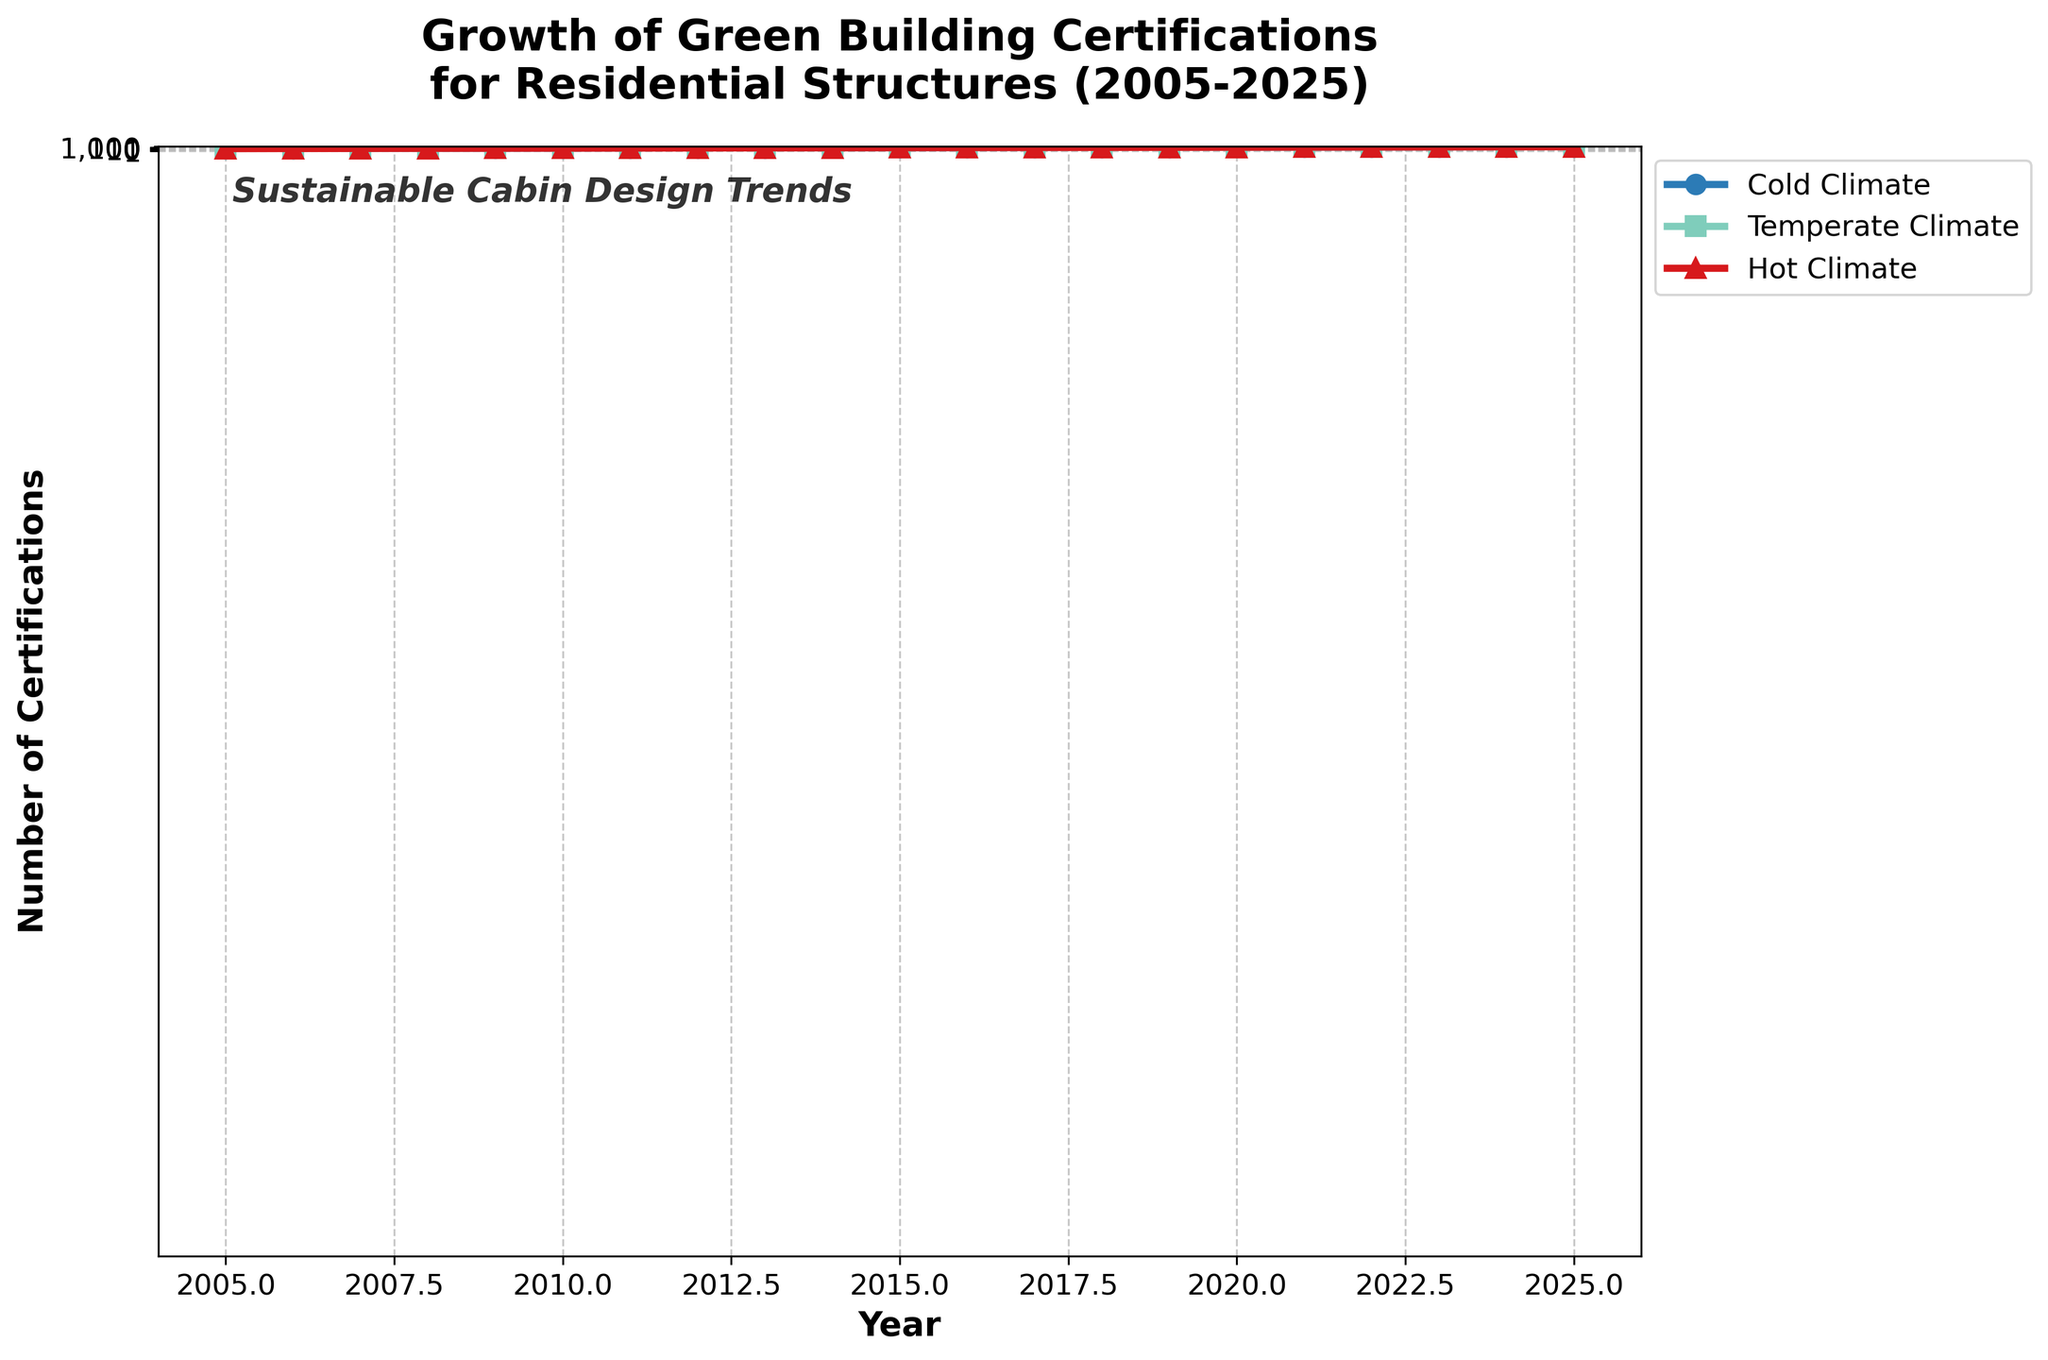What is the overall trend of green building certifications for residential structures in the Cold Climate zone from 2005 to 2025? The figure shows a steadily increasing trend in the number of green building certifications in the Cold Climate zone from 2005 to 2025. This is indicated by the upward slope of the line representing the Cold Climate zone throughout the years.
Answer: Steadily increasing trend Which climate zone exhibited the highest number of certifications in 2020? By examining the figure for the year 2020, the Temperate Climate zone has the highest data point compared to Cold and Hot Climate zones. The green line representing the Temperate Climate zone is significantly above the others for that year.
Answer: Temperate Climate How does the growth rate of certifications in the Hot Climate zone compare to the Cold Climate zone between 2010 and 2015? From 2010 to 2015, the number of certifications in the Hot Climate zone increased from 205 to 545, while in the Cold Climate zone, it increased from 255 to 665. Calculating the growth: Hot Climate increased by 340 (545-205) and Cold Climate increased by 410 (665-255). Thus, the Cold Climate zone had a higher growth rate in certifications during this period.
Answer: Cold Climate had a higher growth rate In which year did the Cold Climate zone surpass 1000 certifications? By analyzing the figure, the Cold Climate line surpasses the 1000-certification mark between 2016 and 2017. The exact year can be determined as 2017 based on the data progression.
Answer: 2017 What is the difference in the number of certifications between the Temperate and Hot Climate zones in 2023? In 2023, the number of certifications for the Temperate Climate zone is 4495, while for the Hot Climate zone it is 2530. The difference can be calculated as 4495 - 2530 = 1965.
Answer: 1965 Describe the visual difference in the lines representing the Cold and Temperate Climate zones. The line for the Cold Climate zone is blue and marked with circles, showing a steady upward trend. The line for the Temperate Climate zone is green and marked with squares, and it is positioned significantly higher and increases at a steeper rate than the Cold Climate line.
Answer: Blue line with circles vs. Green line with squares What was the rate of increase in certifications for the Temperate Climate zone between 2015 and 2020? The number of certifications in the Temperate Climate zone increased from 975 in 2015 to 2535 in 2020. The rate of increase can be calculated as (2535 - 975) / (2020 - 2015) = 312 per year.
Answer: 312 per year Which climate zone had the slowest growth from 2005 to 2025? By visually analyzing the figure, the Hot Climate zone has the lowest increase in the number of certifications over the given period. This is indicated by its position consistently being the lowest compared to the Cold and Temperate Climate zones.
Answer: Hot Climate In 2025, how many more certifications did the Temperate Climate zone have than the Cold Climate zone? In 2025, the number of certifications in the Temperate Climate zone is 6580, while in the Cold Climate zone it is 4495. The difference can be calculated as 6580 - 4495 = 2085.
Answer: 2085 